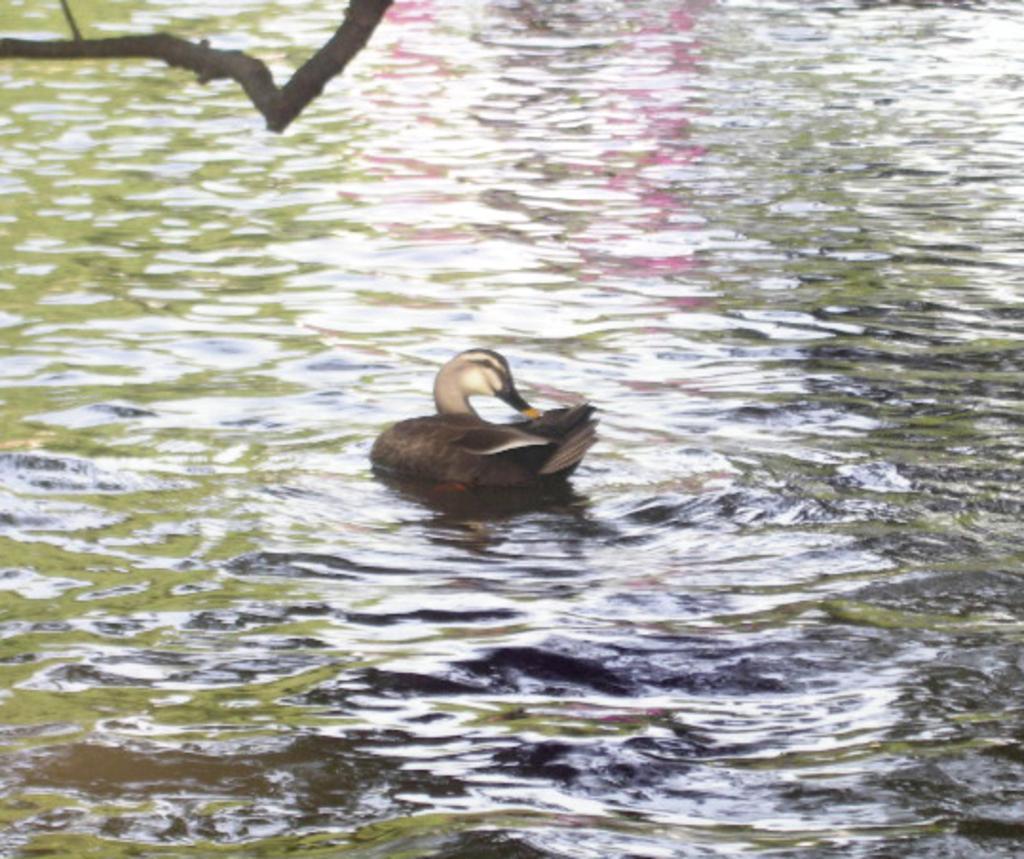Can you describe this image briefly? In this image I can see the bird on the water. The bird is in black and cream color. To the left I can see the branch of the tree. 